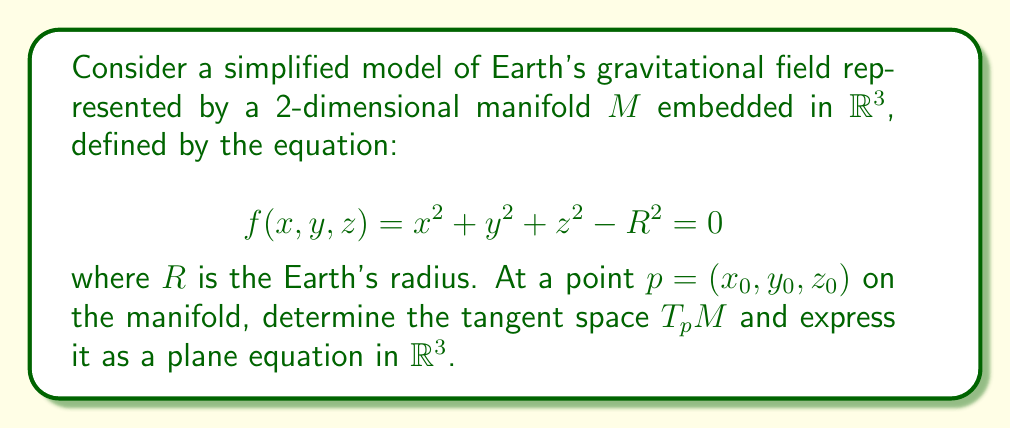Give your solution to this math problem. To solve this problem, we'll follow these steps:

1) The tangent space $T_pM$ at a point $p$ on the manifold $M$ is the set of all vectors orthogonal to the gradient of $f$ at $p$.

2) First, we need to calculate the gradient of $f$:
   $$\nabla f = \left(\frac{\partial f}{\partial x}, \frac{\partial f}{\partial y}, \frac{\partial f}{\partial z}\right) = (2x, 2y, 2z)$$

3) At the point $p = (x_0, y_0, z_0)$, the gradient is:
   $$\nabla f|_p = (2x_0, 2y_0, 2z_0)$$

4) The tangent space $T_pM$ consists of all vectors $v = (a, b, c)$ that are orthogonal to $\nabla f|_p$. This can be expressed using the dot product:

   $$(2x_0, 2y_0, 2z_0) \cdot (a, b, c) = 0$$

5) Expanding this equation:
   $$2x_0a + 2y_0b + 2z_0c = 0$$
   $$x_0a + y_0b + z_0c = 0$$

6) This is the equation of a plane in $\mathbb{R}^3$, which represents the tangent space $T_pM$ at the point $p$.

7) To express this as a standard plane equation $Ax + By + Cz + D = 0$, we can rewrite it as:
   $$x_0x + y_0y + z_0z = x_0x_0 + y_0y_0 + z_0z_0 = R^2$$

   The last equality comes from the fact that $p$ is on the manifold, so $x_0^2 + y_0^2 + z_0^2 = R^2$.

Therefore, the equation of the tangent plane (representing the tangent space) is:
$$x_0x + y_0y + z_0z - R^2 = 0$$
Answer: The tangent space $T_pM$ at the point $p = (x_0, y_0, z_0)$ on the manifold $M$ is represented by the plane:

$$x_0x + y_0y + z_0z - R^2 = 0$$

where $R$ is the radius of the Earth, and $(x_0, y_0, z_0)$ satisfies $x_0^2 + y_0^2 + z_0^2 = R^2$. 